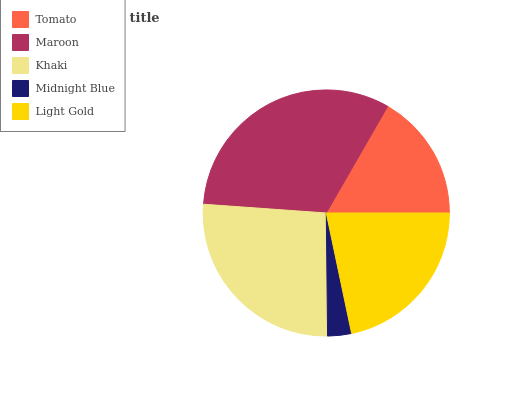Is Midnight Blue the minimum?
Answer yes or no. Yes. Is Maroon the maximum?
Answer yes or no. Yes. Is Khaki the minimum?
Answer yes or no. No. Is Khaki the maximum?
Answer yes or no. No. Is Maroon greater than Khaki?
Answer yes or no. Yes. Is Khaki less than Maroon?
Answer yes or no. Yes. Is Khaki greater than Maroon?
Answer yes or no. No. Is Maroon less than Khaki?
Answer yes or no. No. Is Light Gold the high median?
Answer yes or no. Yes. Is Light Gold the low median?
Answer yes or no. Yes. Is Tomato the high median?
Answer yes or no. No. Is Tomato the low median?
Answer yes or no. No. 